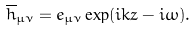<formula> <loc_0><loc_0><loc_500><loc_500>\overline { h } _ { \mu \nu } = e _ { \mu \nu } \exp ( i k z - i \omega ) .</formula> 